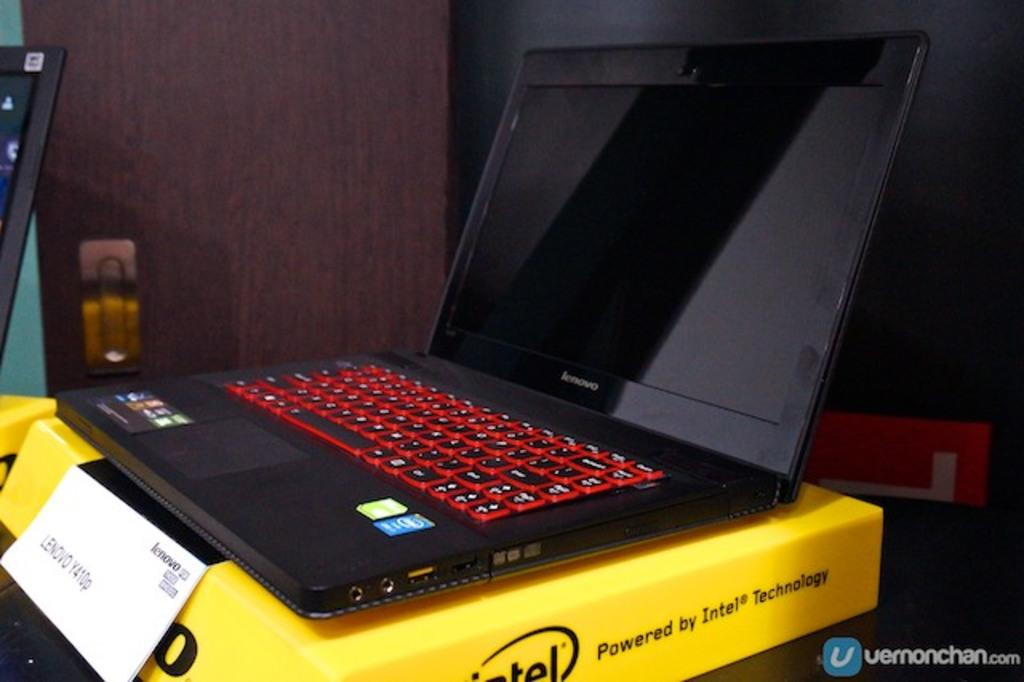<image>
Write a terse but informative summary of the picture. a levovo y410p intel laptop with gaming keyboard 